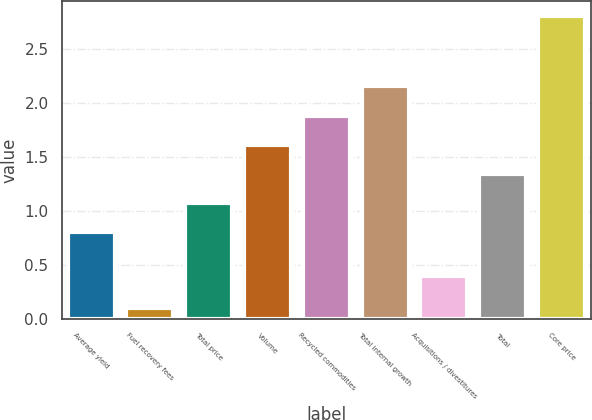Convert chart to OTSL. <chart><loc_0><loc_0><loc_500><loc_500><bar_chart><fcel>Average yield<fcel>Fuel recovery fees<fcel>Total price<fcel>Volume<fcel>Recycled commodities<fcel>Total internal growth<fcel>Acquisitions / divestitures<fcel>Total<fcel>Core price<nl><fcel>0.8<fcel>0.1<fcel>1.07<fcel>1.61<fcel>1.88<fcel>2.15<fcel>0.4<fcel>1.34<fcel>2.8<nl></chart> 